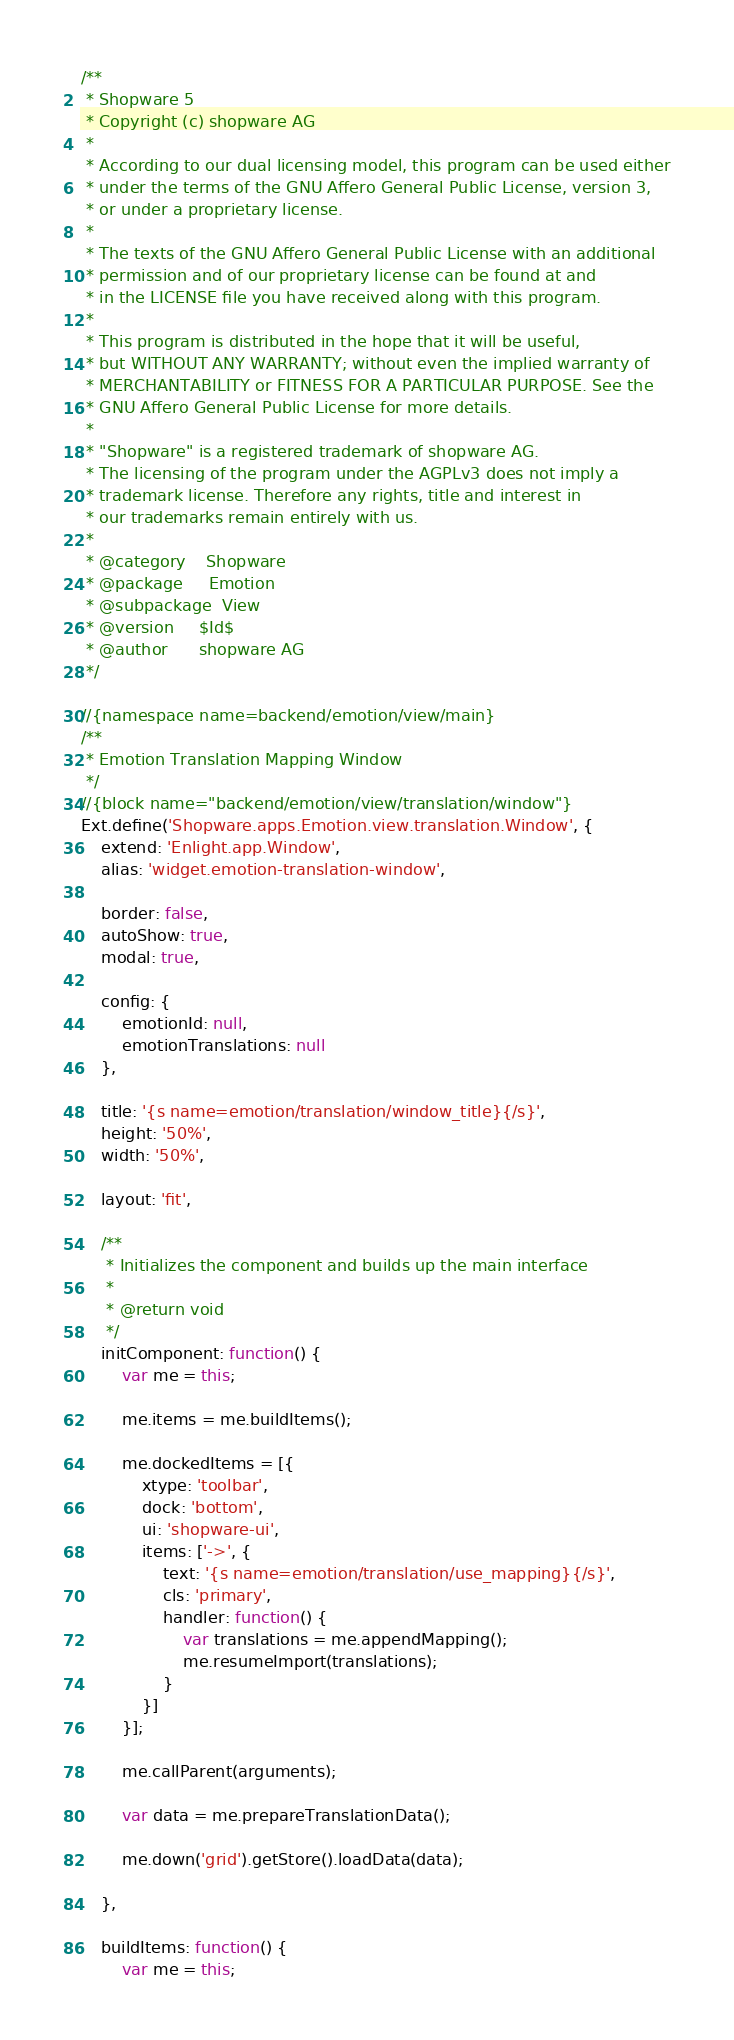<code> <loc_0><loc_0><loc_500><loc_500><_JavaScript_>/**
 * Shopware 5
 * Copyright (c) shopware AG
 *
 * According to our dual licensing model, this program can be used either
 * under the terms of the GNU Affero General Public License, version 3,
 * or under a proprietary license.
 *
 * The texts of the GNU Affero General Public License with an additional
 * permission and of our proprietary license can be found at and
 * in the LICENSE file you have received along with this program.
 *
 * This program is distributed in the hope that it will be useful,
 * but WITHOUT ANY WARRANTY; without even the implied warranty of
 * MERCHANTABILITY or FITNESS FOR A PARTICULAR PURPOSE. See the
 * GNU Affero General Public License for more details.
 *
 * "Shopware" is a registered trademark of shopware AG.
 * The licensing of the program under the AGPLv3 does not imply a
 * trademark license. Therefore any rights, title and interest in
 * our trademarks remain entirely with us.
 *
 * @category    Shopware
 * @package     Emotion
 * @subpackage  View
 * @version     $Id$
 * @author      shopware AG
 */

//{namespace name=backend/emotion/view/main}
/**
 * Emotion Translation Mapping Window
 */
//{block name="backend/emotion/view/translation/window"}
Ext.define('Shopware.apps.Emotion.view.translation.Window', {
    extend: 'Enlight.app.Window',
    alias: 'widget.emotion-translation-window',

    border: false,
    autoShow: true,
    modal: true,

    config: {
        emotionId: null,
        emotionTranslations: null
    },

    title: '{s name=emotion/translation/window_title}{/s}',
    height: '50%',
    width: '50%',

    layout: 'fit',

    /**
     * Initializes the component and builds up the main interface
     *
     * @return void
     */
    initComponent: function() {
        var me = this;

        me.items = me.buildItems();

        me.dockedItems = [{
            xtype: 'toolbar',
            dock: 'bottom',
            ui: 'shopware-ui',
            items: ['->', {
                text: '{s name=emotion/translation/use_mapping}{/s}',
                cls: 'primary',
                handler: function() {
                    var translations = me.appendMapping();
                    me.resumeImport(translations);
                }
            }]
        }];

        me.callParent(arguments);

        var data = me.prepareTranslationData();

        me.down('grid').getStore().loadData(data);

    },

    buildItems: function() {
        var me = this;
</code> 